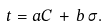<formula> <loc_0><loc_0><loc_500><loc_500>t = a C \, + \, b \, \sigma .</formula> 